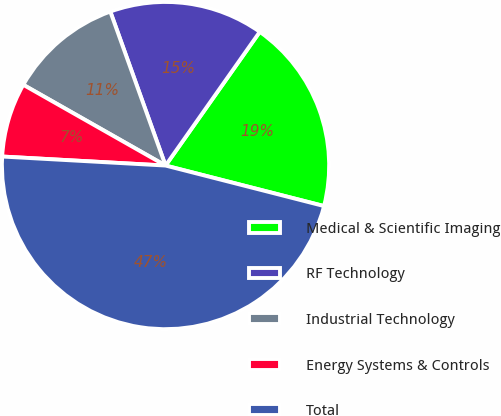Convert chart. <chart><loc_0><loc_0><loc_500><loc_500><pie_chart><fcel>Medical & Scientific Imaging<fcel>RF Technology<fcel>Industrial Technology<fcel>Energy Systems & Controls<fcel>Total<nl><fcel>19.21%<fcel>15.25%<fcel>11.3%<fcel>7.34%<fcel>46.89%<nl></chart> 